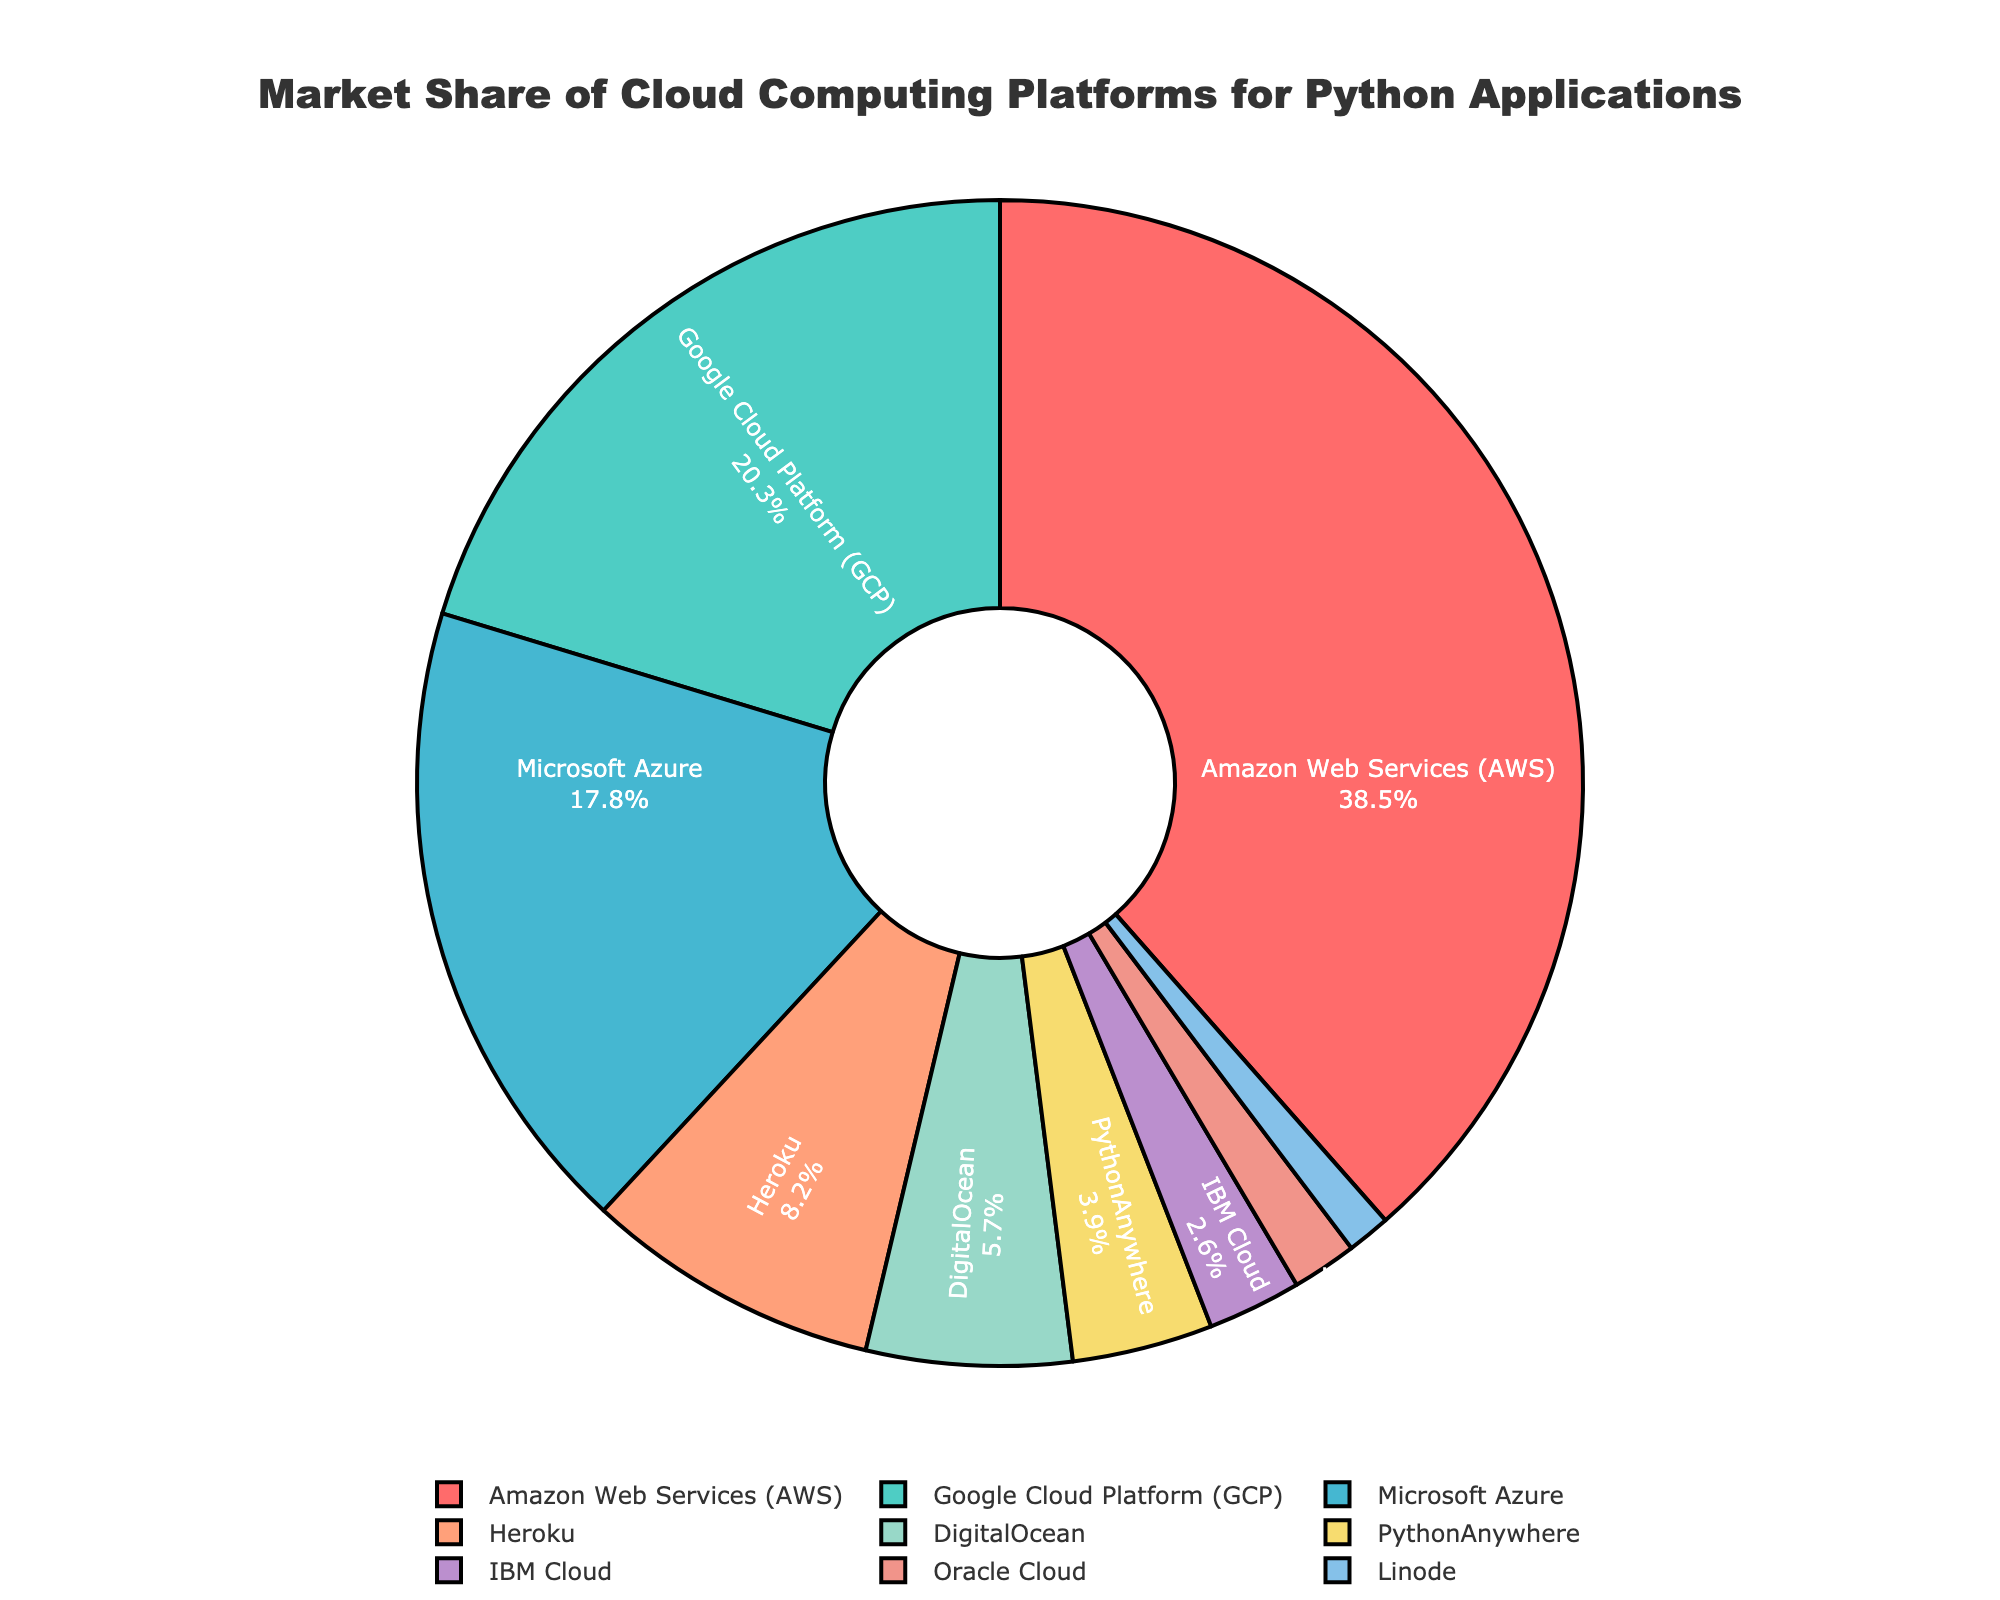Which platform has the highest market share? By looking at the figure, it is clear that Amazon Web Services (AWS) has the largest portion of the pie chart.
Answer: Amazon Web Services (AWS) Which two platforms have the closest market shares? The figure shows that Google Cloud Platform (GCP) and Microsoft Azure have quite close market shares. Specifically, GCP has a share of 20.3%, and Azure has 17.8%.
Answer: Google Cloud Platform (GCP) and Microsoft Azure What is the combined market share of Heroku and DigitalOcean? To find the combined market share of Heroku and DigitalOcean, add their individual market shares: Heroku (8.2%) + DigitalOcean (5.7%) = 13.9%.
Answer: 13.9% Which platform has a larger market share, IBM Cloud or Oracle Cloud? And by how much? IBM Cloud has a market share of 2.6%, and Oracle Cloud has a market share of 1.8%. The difference is 2.6% - 1.8% = 0.8%.
Answer: IBM Cloud by 0.8% What is the sum of market shares for all platforms below 5%? Platforms below 5% are PythonAnywhere (3.9%), IBM Cloud (2.6%), Oracle Cloud (1.8%), and Linode (1.2%). The sum is 3.9% + 2.6% + 1.8% + 1.2% = 9.5%.
Answer: 9.5% What is the second largest platform in terms of market share? By examining the pie chart, the second largest market share is taken by Google Cloud Platform (GCP) with 20.3%.
Answer: Google Cloud Platform (GCP) Which two platforms' combined market share is roughly equal to Amazon Web Services (AWS)? AWS has a market share of 38.5%. Adding the shares of Google Cloud Platform (GCP) at 20.3% and Microsoft Azure at 17.8% gives 20.3% + 17.8% = 38.1%, which is roughly equal to AWS's market share.
Answer: Google Cloud Platform (GCP) and Microsoft Azure What is the average market share of all the platforms shown in the figure? To find the average, sum all the market shares: 38.5 + 20.3 + 17.8 + 8.2 + 5.7 + 3.9 + 2.6 + 1.8 + 1.2 = 100. Then, divide by the number of platforms: 100 / 9 ≈ 11.1%.
Answer: 11.1% What color represents DigitalOcean in the pie chart? The pie chart uses specific colors for each platform, and DigitalOcean is represented by a light greenish color.
Answer: light greenish Is the market share of Linode less than the combination of IBM Cloud and Oracle Cloud? Linode has a market share of 1.2%, while IBM Cloud (2.6%) + Oracle Cloud (1.8%) = 4.4%. Since 1.2% < 4.4%, Linode’s market share is indeed less than the combined share of IBM Cloud and Oracle Cloud.
Answer: Yes 